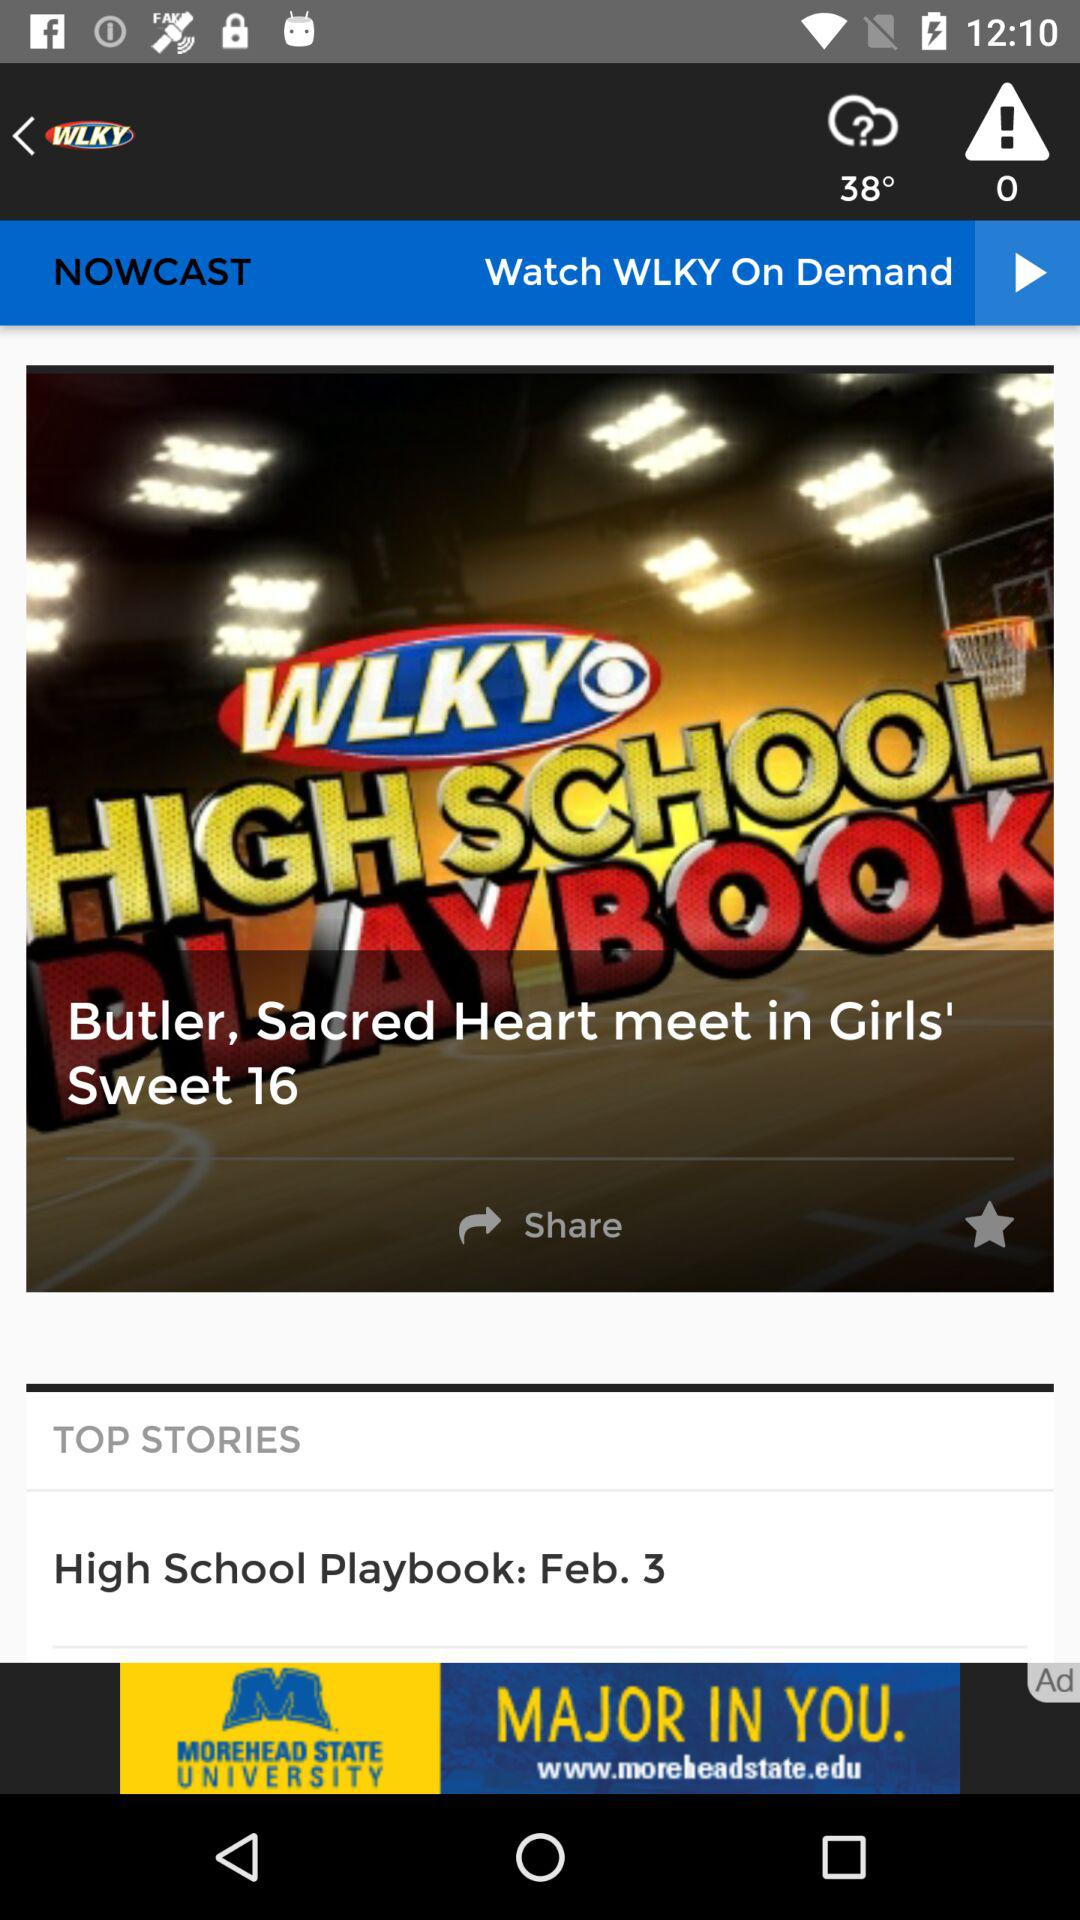What is the date of "High School Playbook"? The date of "High School Playbook" is February 3. 